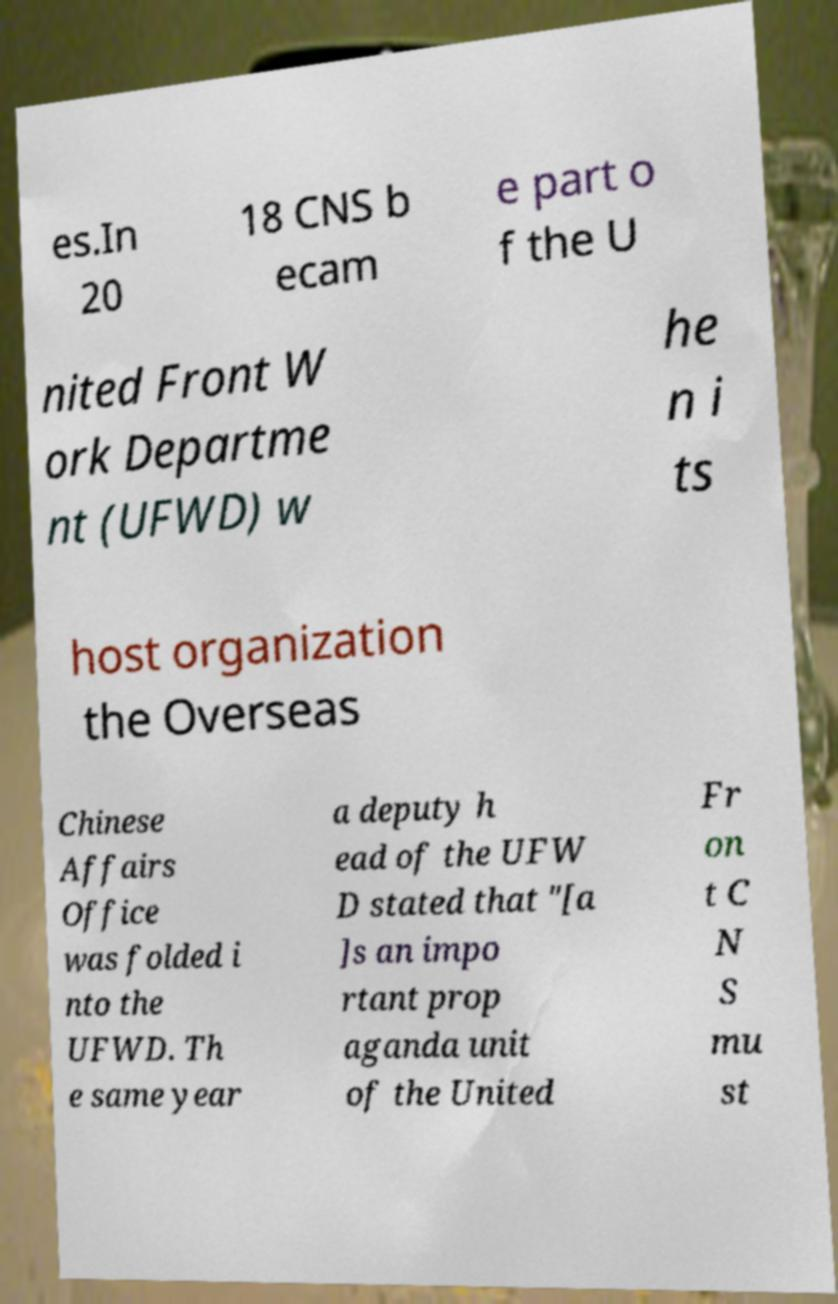Could you extract and type out the text from this image? es.In 20 18 CNS b ecam e part o f the U nited Front W ork Departme nt (UFWD) w he n i ts host organization the Overseas Chinese Affairs Office was folded i nto the UFWD. Th e same year a deputy h ead of the UFW D stated that "[a ]s an impo rtant prop aganda unit of the United Fr on t C N S mu st 